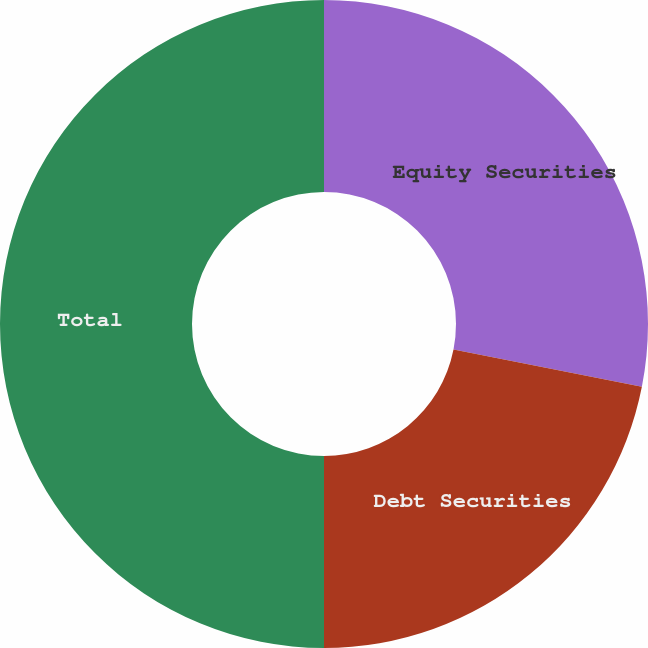<chart> <loc_0><loc_0><loc_500><loc_500><pie_chart><fcel>Equity Securities<fcel>Debt Securities<fcel>Total<nl><fcel>28.1%<fcel>21.9%<fcel>50.0%<nl></chart> 